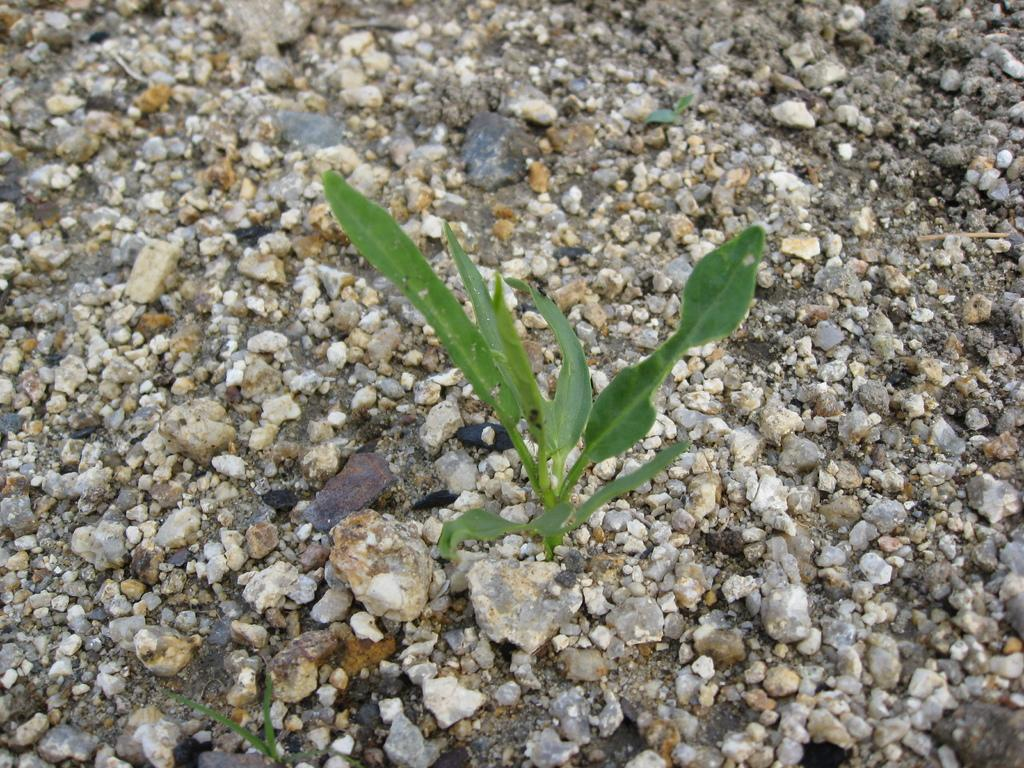What type of objects can be seen in the image? There are stones in the image. What is located in the middle of the image? There is a plant in the middle of the image. What type of jam is being spread on the territory in the image? There is no jam or territory present in the image; it only features stones and a plant. What type of bird can be seen perched on the plant in the image? There are no birds present in the image; it only features stones and a plant. 